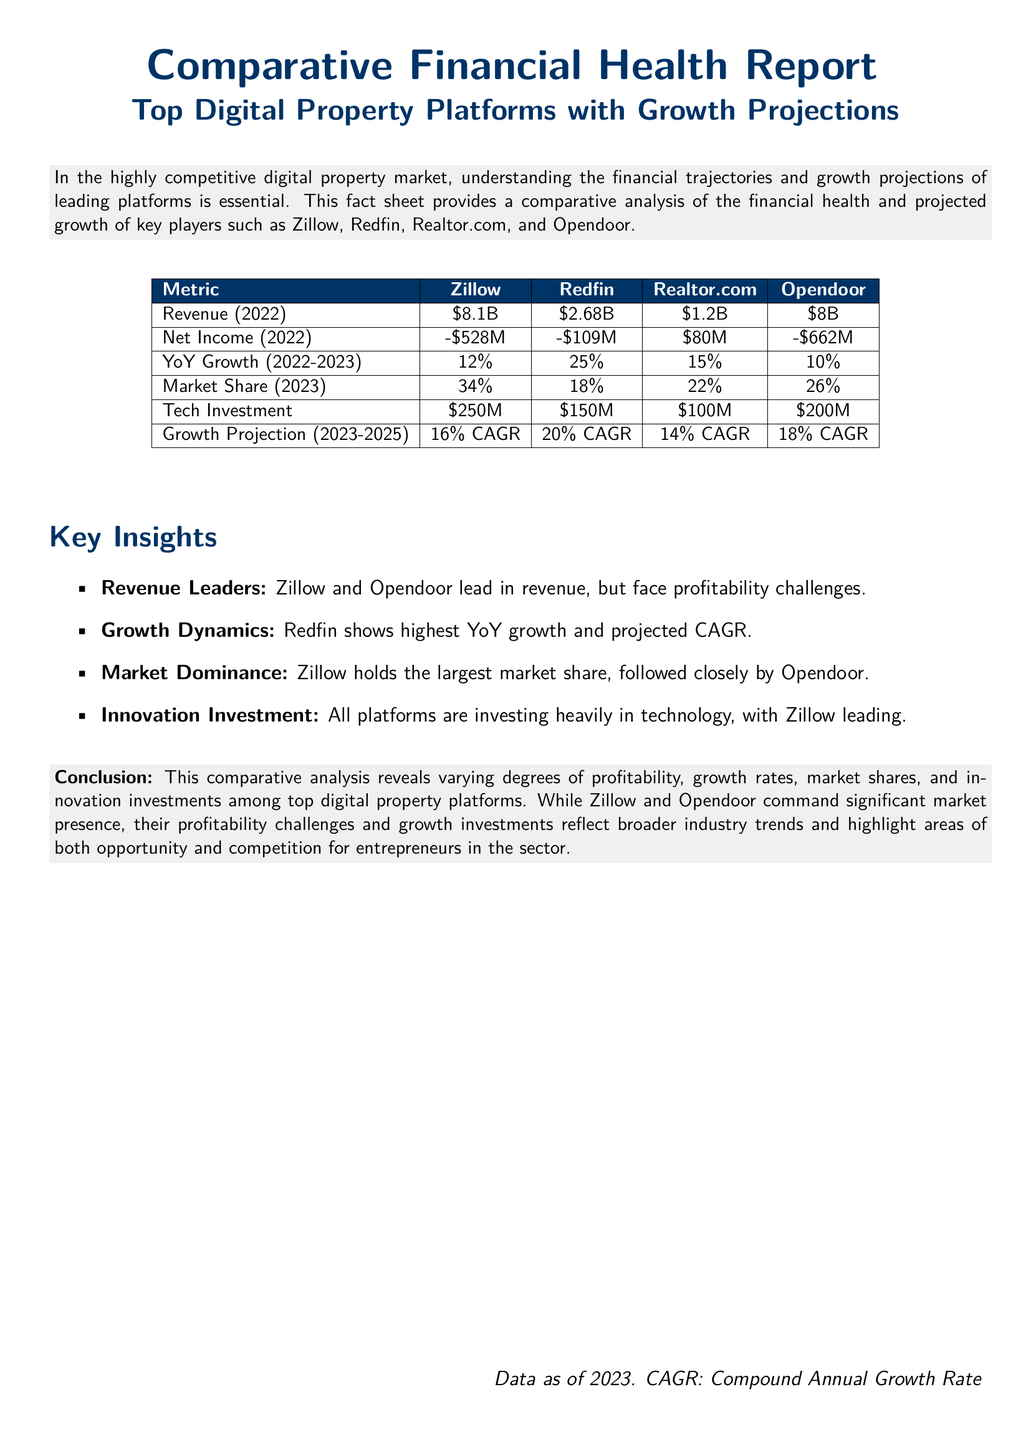What was Zillow's revenue in 2022? The document states that Zillow's revenue for 2022 was \$8.1B.
Answer: \$8.1B What is Redfin's Year-over-Year growth for 2022-2023? The Year-over-Year growth for Redfin from 2022 to 2023 is mentioned as 25%.
Answer: 25% Which platform has the lowest net income in 2022? The document indicates that Opendoor had the lowest net income in 2022 at -\$662M.
Answer: -\$662M What is the market share of Realtor.com in 2023? The market share of Realtor.com in 2023 is specified as 22%.
Answer: 22% Which platform is projected to have the highest CAGR from 2023 to 2025? Redfin is noted to have the highest projected Compound Annual Growth Rate (CAGR) at 20% from 2023 to 2025.
Answer: 20% What is the total tech investment by Zillow and Opendoor combined? The total tech investment for both Zillow and Opendoor is the sum of \$250M and \$200M, which is \$450M.
Answer: \$450M What does the report suggest about Zillow and Opendoor? The report highlights that Zillow and Opendoor lead in revenue but face profitability challenges.
Answer: Profitability challenges How does the growth projection for Realtor.com compare to that of Opendoor? The document indicates that Realtor.com has a 14% CAGR, while Opendoor has an 18% CAGR, showing Opendoor's higher growth projection.
Answer: 18% CAGR vs 14% CAGR What key insight is provided regarding technology investment among the platforms? The report states that all platforms are heavily investing in technology, with Zillow leading the investment.
Answer: Zillow leading 